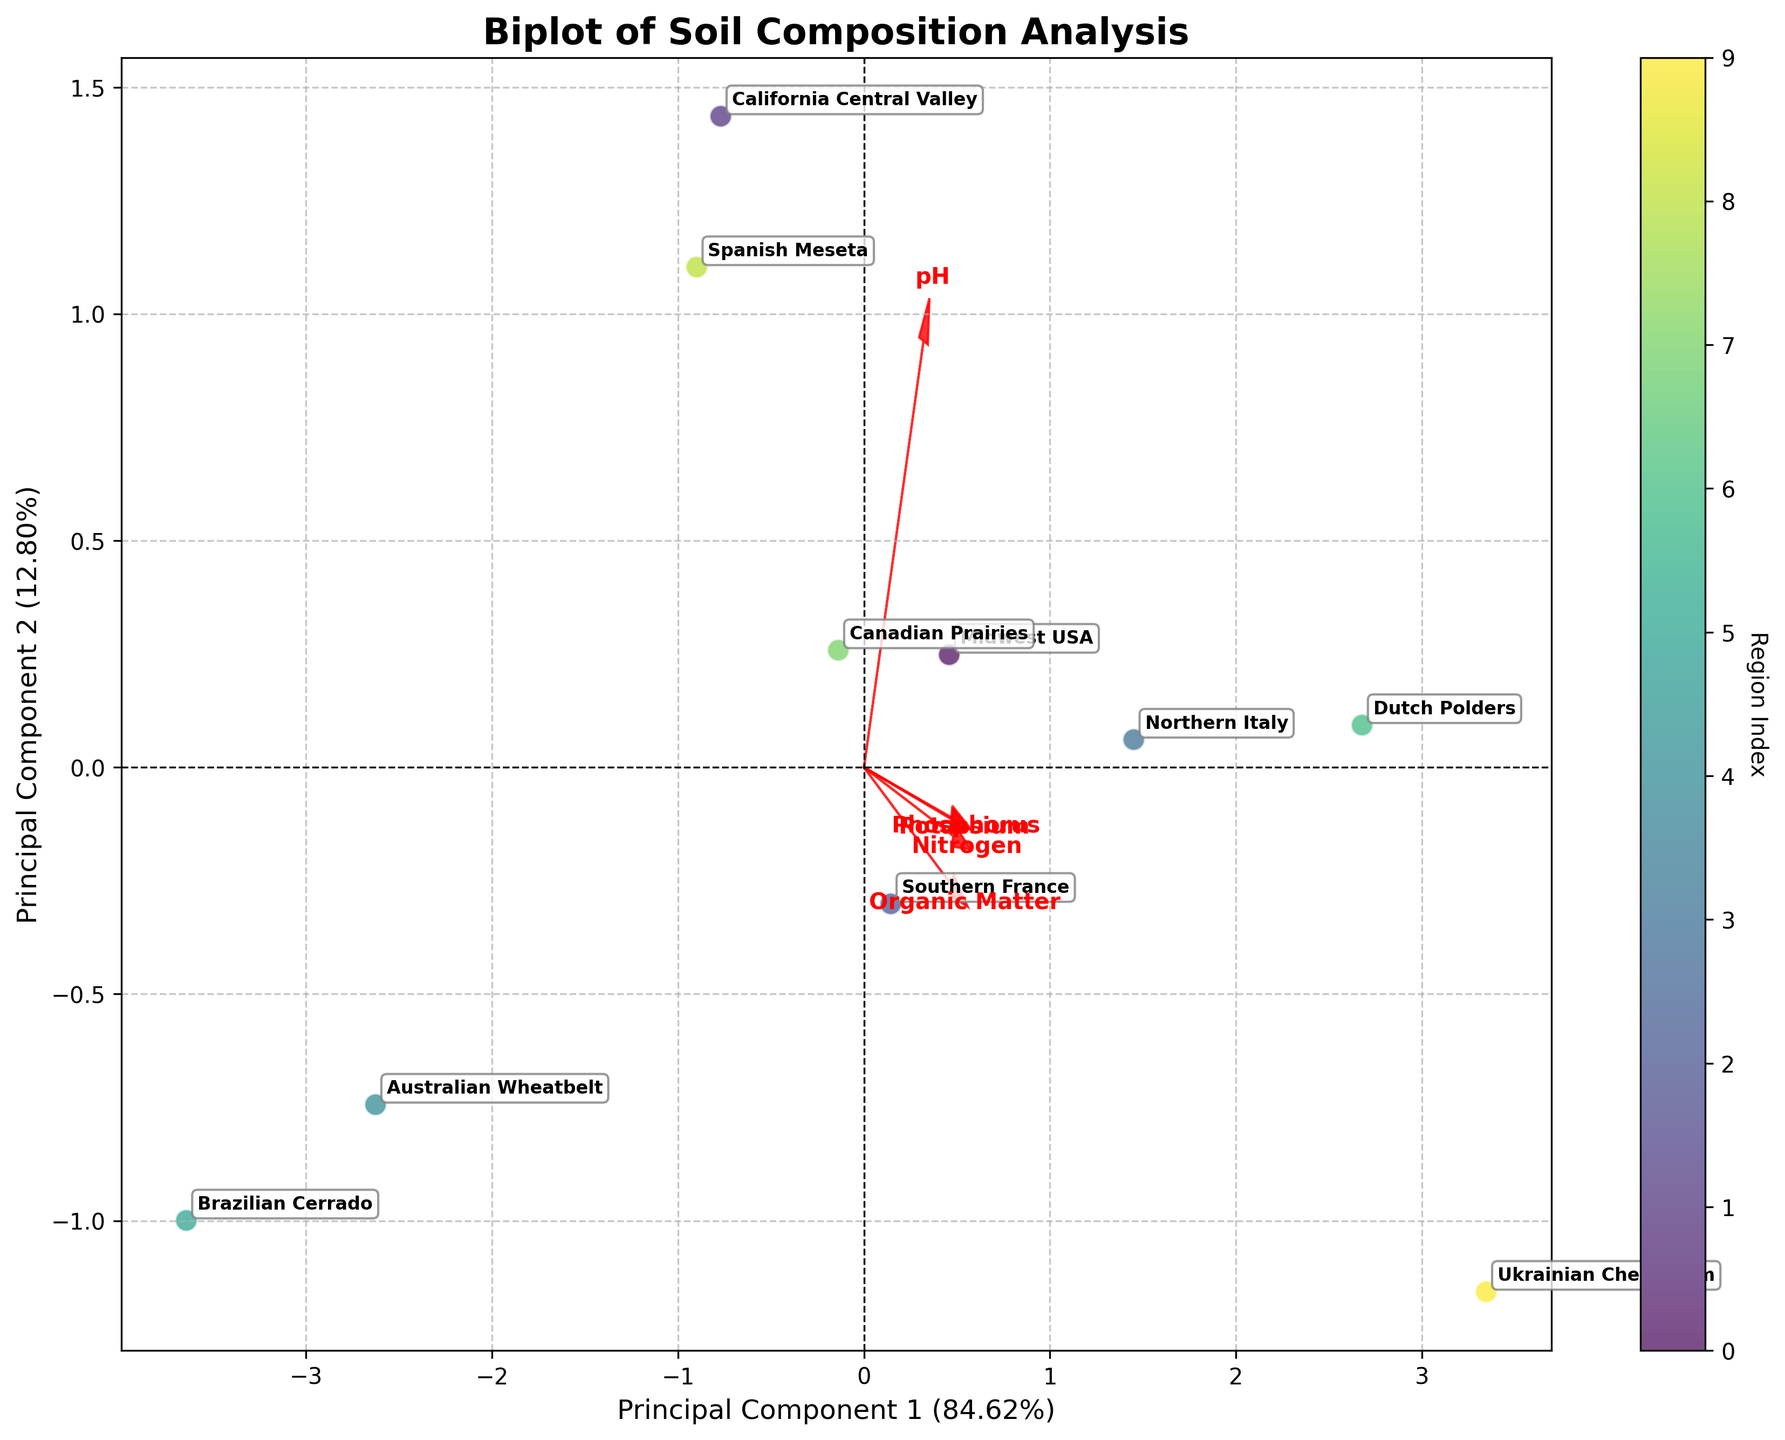How many regions are displayed in the biplot? Count the number of distinct regions annotated in the biplot.
Answer: 10 Which region has the highest pH value? Identify the region corresponding to the highest pH loading on the plot. Look for pH loadings pointing towards the region with the highest magnitude.
Answer: California Central Valley Which regions have similar organic matter content levels? Look at the clustering of regions close to the line representing organic matter loadings in the biplot. Regions near each other along the organic matter vector are similar in organic content.
Answer: Midwest USA, Northern Italy, Dutch Polders Between Canadian Prairies and Brazilian Cerrado, which is better for potassium content? Compare their positions along the potassium vector. The region closer to the positive direction of the potassium vector has higher potassium content.
Answer: Canadian Prairies How do nutrient levels and pH affect the spread of data points? Observe the length and direction of the arrows representing nutrient and pH loadings. Nutrients and pH with longer arrows have a greater influence on the distribution of regions in the biplot.
Answer: Long arrows indicate significant effect Identify the region with the most balanced composition of nutrients and pH. Look for the region that is approximately equidistant from all loadings vectors. This region would likely have balanced levels across all measured factors.
Answer: Southern France Which principal component explains more variance? Compare the percentage values labeled on the axes for Principal Component 1 and Principal Component 2. The component with the higher percentage explains more variance.
Answer: Principal Component 1 How does the Brazilian Cerrado compare in phosphorus content with the Dutch Polders? Compare their positions relative to the phosphorus vector. The region closer in the direction of the phosphorus vector has higher content.
Answer: Dutch Polders What's the relationship between nitrogen content and organic matter? Examine the angles between the vectors for nitrogen and organic matter. The acute angle indicates a positive relationship, while an obtuse angle indicates a negative relationship.
Answer: Positive relationship Identify the region with the highest nitrogen content. Look at the direction of the nitrogen vector; the region farthest along the vector in the positive direction has the highest nitrogen content.
Answer: Ukrainian Chernozem 